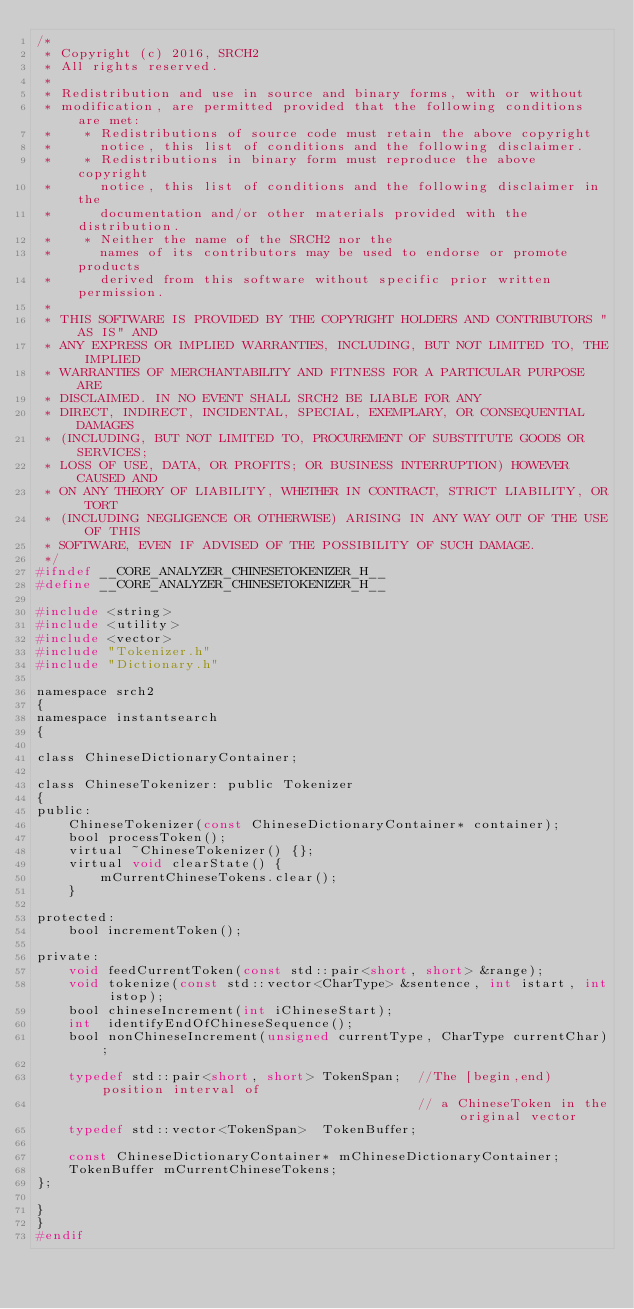<code> <loc_0><loc_0><loc_500><loc_500><_C_>/*
 * Copyright (c) 2016, SRCH2
 * All rights reserved.
 * 
 * Redistribution and use in source and binary forms, with or without
 * modification, are permitted provided that the following conditions are met:
 *    * Redistributions of source code must retain the above copyright
 *      notice, this list of conditions and the following disclaimer.
 *    * Redistributions in binary form must reproduce the above copyright
 *      notice, this list of conditions and the following disclaimer in the
 *      documentation and/or other materials provided with the distribution.
 *    * Neither the name of the SRCH2 nor the
 *      names of its contributors may be used to endorse or promote products
 *      derived from this software without specific prior written permission.
 * 
 * THIS SOFTWARE IS PROVIDED BY THE COPYRIGHT HOLDERS AND CONTRIBUTORS "AS IS" AND
 * ANY EXPRESS OR IMPLIED WARRANTIES, INCLUDING, BUT NOT LIMITED TO, THE IMPLIED
 * WARRANTIES OF MERCHANTABILITY AND FITNESS FOR A PARTICULAR PURPOSE ARE
 * DISCLAIMED. IN NO EVENT SHALL SRCH2 BE LIABLE FOR ANY
 * DIRECT, INDIRECT, INCIDENTAL, SPECIAL, EXEMPLARY, OR CONSEQUENTIAL DAMAGES
 * (INCLUDING, BUT NOT LIMITED TO, PROCUREMENT OF SUBSTITUTE GOODS OR SERVICES;
 * LOSS OF USE, DATA, OR PROFITS; OR BUSINESS INTERRUPTION) HOWEVER CAUSED AND
 * ON ANY THEORY OF LIABILITY, WHETHER IN CONTRACT, STRICT LIABILITY, OR TORT
 * (INCLUDING NEGLIGENCE OR OTHERWISE) ARISING IN ANY WAY OUT OF THE USE OF THIS
 * SOFTWARE, EVEN IF ADVISED OF THE POSSIBILITY OF SUCH DAMAGE.
 */
#ifndef __CORE_ANALYZER_CHINESETOKENIZER_H__
#define __CORE_ANALYZER_CHINESETOKENIZER_H__

#include <string>
#include <utility>
#include <vector>
#include "Tokenizer.h"
#include "Dictionary.h"

namespace srch2
{
namespace instantsearch
{

class ChineseDictionaryContainer;

class ChineseTokenizer: public Tokenizer
{
public:
    ChineseTokenizer(const ChineseDictionaryContainer* container);
    bool processToken();
    virtual ~ChineseTokenizer() {};
    virtual void clearState() {     
        mCurrentChineseTokens.clear();
    }

protected:
    bool incrementToken();

private:
    void feedCurrentToken(const std::pair<short, short> &range);
    void tokenize(const std::vector<CharType> &sentence, int istart, int istop);
    bool chineseIncrement(int iChineseStart);
    int  identifyEndOfChineseSequence();
    bool nonChineseIncrement(unsigned currentType, CharType currentChar);

    typedef std::pair<short, short> TokenSpan;  //The [begin,end) position interval of 
                                                // a ChineseToken in the original vector 
    typedef std::vector<TokenSpan>  TokenBuffer;

    const ChineseDictionaryContainer* mChineseDictionaryContainer;
    TokenBuffer mCurrentChineseTokens;
};

}
}
#endif
</code> 